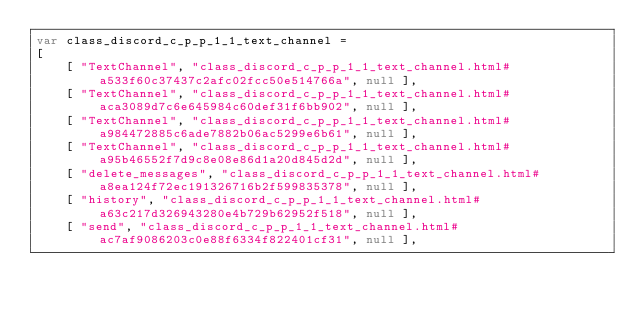Convert code to text. <code><loc_0><loc_0><loc_500><loc_500><_JavaScript_>var class_discord_c_p_p_1_1_text_channel =
[
    [ "TextChannel", "class_discord_c_p_p_1_1_text_channel.html#a533f60c37437c2afc02fcc50e514766a", null ],
    [ "TextChannel", "class_discord_c_p_p_1_1_text_channel.html#aca3089d7c6e645984c60def31f6bb902", null ],
    [ "TextChannel", "class_discord_c_p_p_1_1_text_channel.html#a984472885c6ade7882b06ac5299e6b61", null ],
    [ "TextChannel", "class_discord_c_p_p_1_1_text_channel.html#a95b46552f7d9c8e08e86d1a20d845d2d", null ],
    [ "delete_messages", "class_discord_c_p_p_1_1_text_channel.html#a8ea124f72ec191326716b2f599835378", null ],
    [ "history", "class_discord_c_p_p_1_1_text_channel.html#a63c217d326943280e4b729b62952f518", null ],
    [ "send", "class_discord_c_p_p_1_1_text_channel.html#ac7af9086203c0e88f6334f822401cf31", null ],</code> 